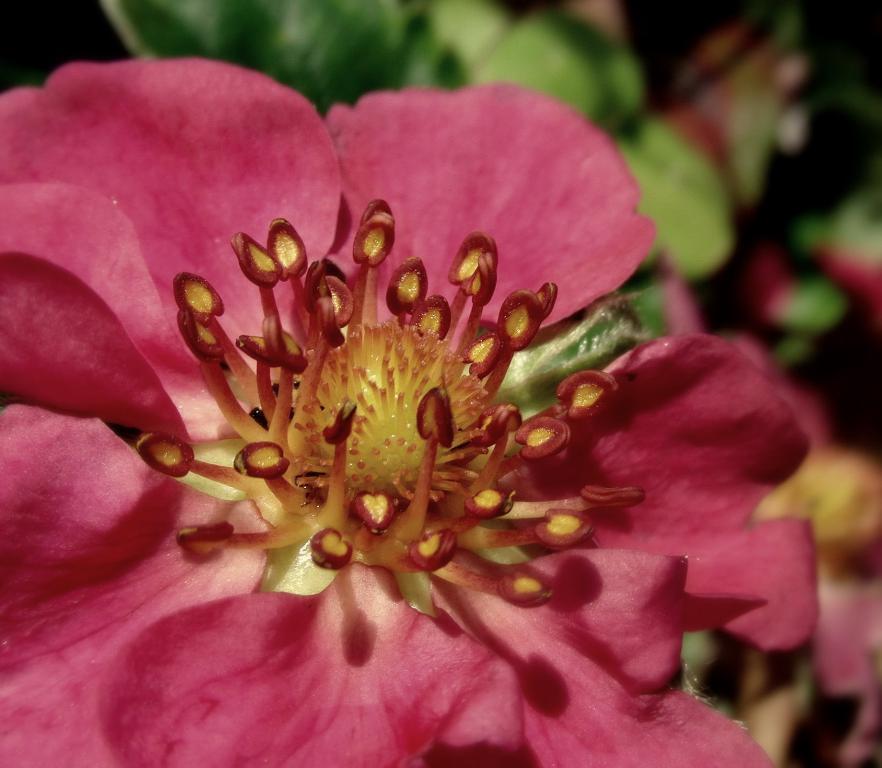Please provide a concise description of this image. In this picture we can see a flower and in the background we can see leaves and it is blurry. 